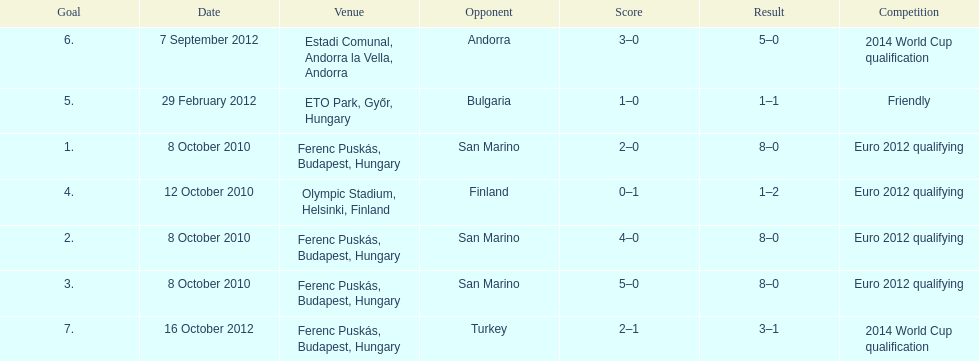What is the total number of international goals ádám szalai has made? 7. 